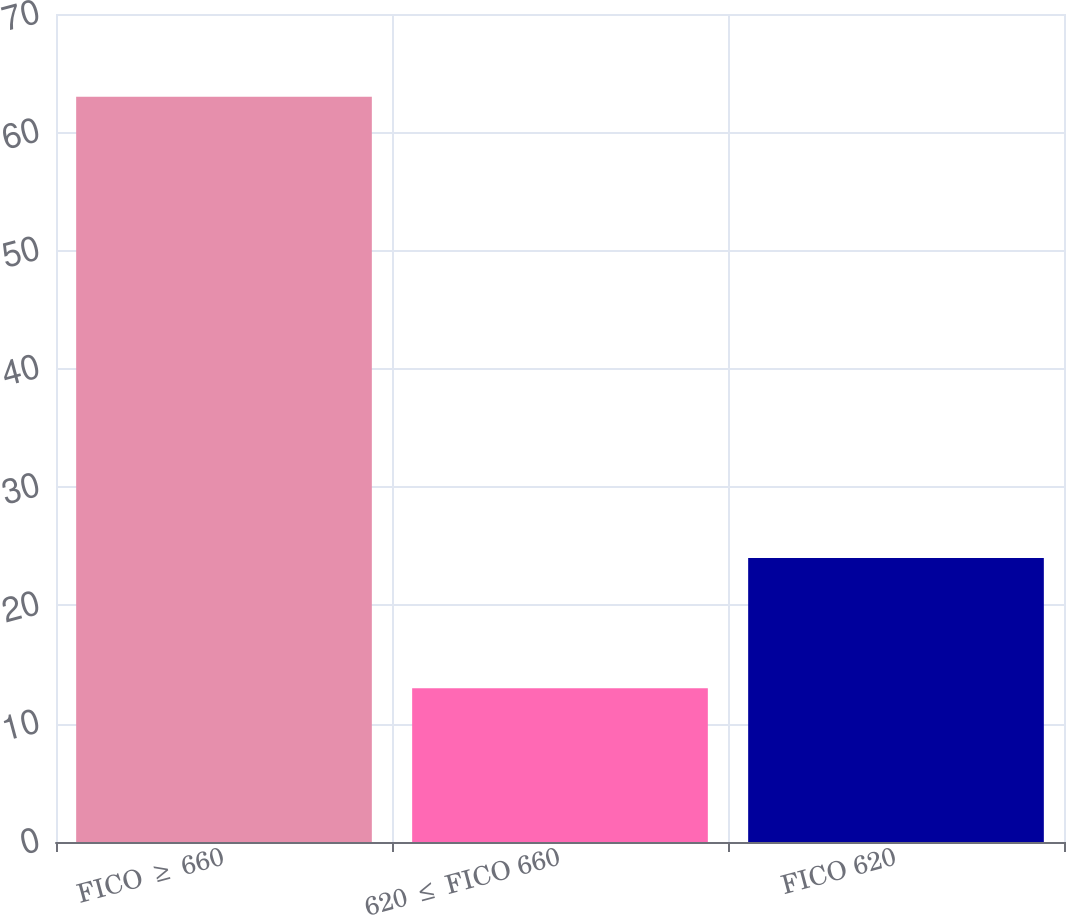Convert chart. <chart><loc_0><loc_0><loc_500><loc_500><bar_chart><fcel>FICO ≥ 660<fcel>620 ≤ FICO 660<fcel>FICO 620<nl><fcel>63<fcel>13<fcel>24<nl></chart> 